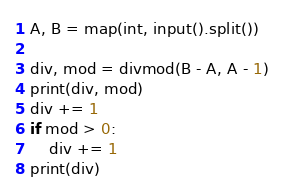<code> <loc_0><loc_0><loc_500><loc_500><_Python_>A, B = map(int, input().split())

div, mod = divmod(B - A, A - 1)
print(div, mod)
div += 1
if mod > 0:
    div += 1
print(div)
</code> 